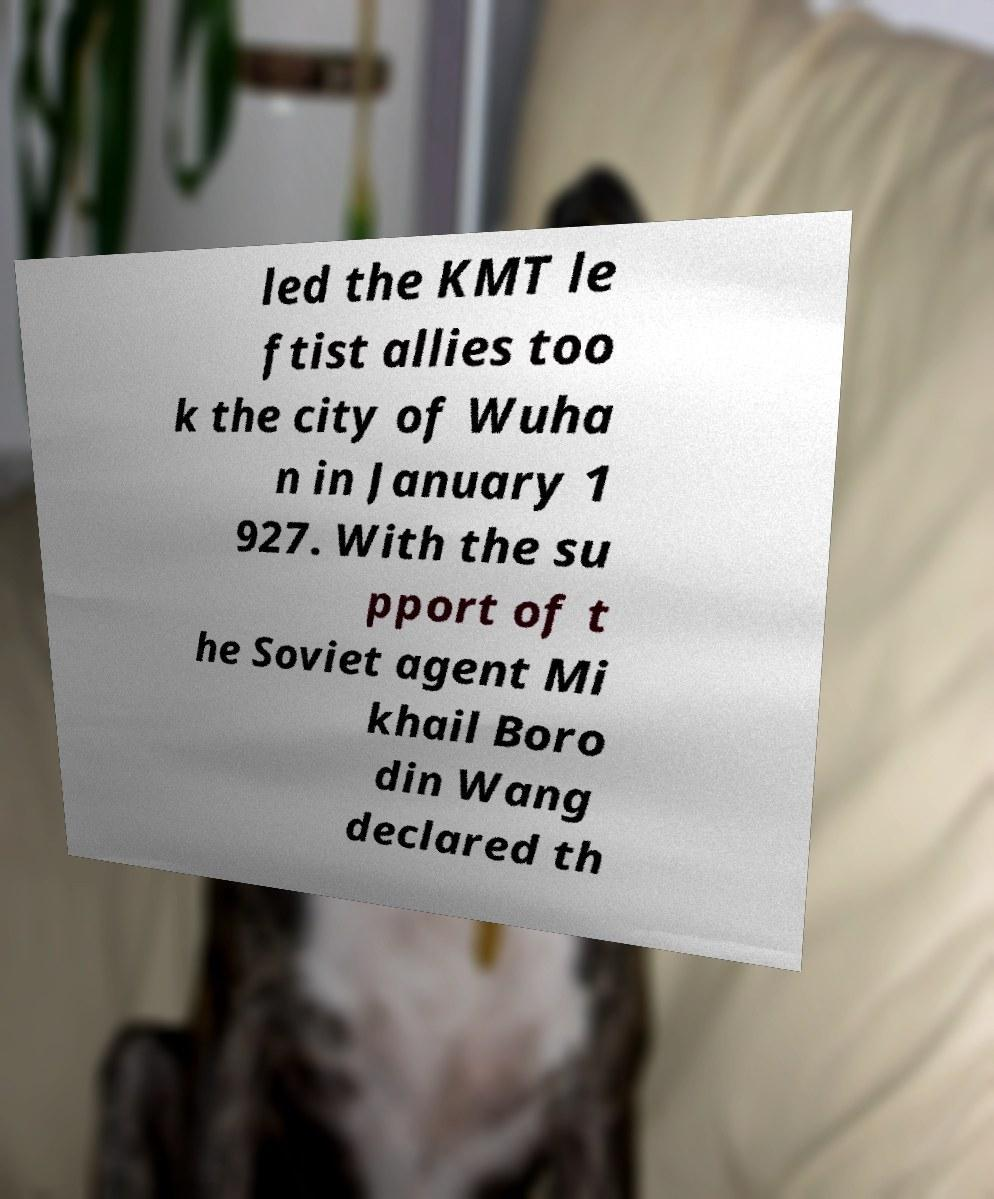Can you read and provide the text displayed in the image?This photo seems to have some interesting text. Can you extract and type it out for me? led the KMT le ftist allies too k the city of Wuha n in January 1 927. With the su pport of t he Soviet agent Mi khail Boro din Wang declared th 